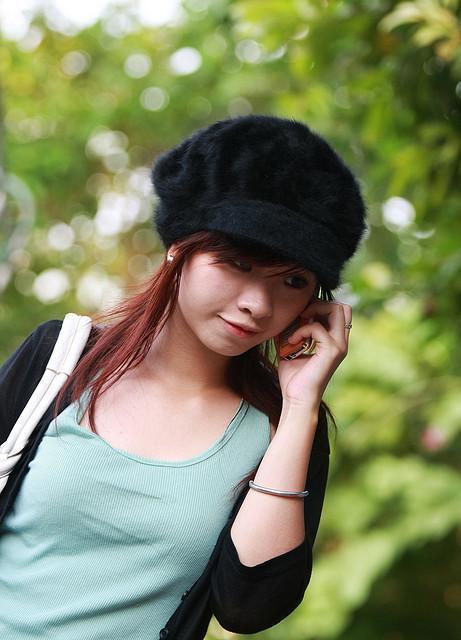How many cat tails are visible in the image?
Give a very brief answer. 0. 